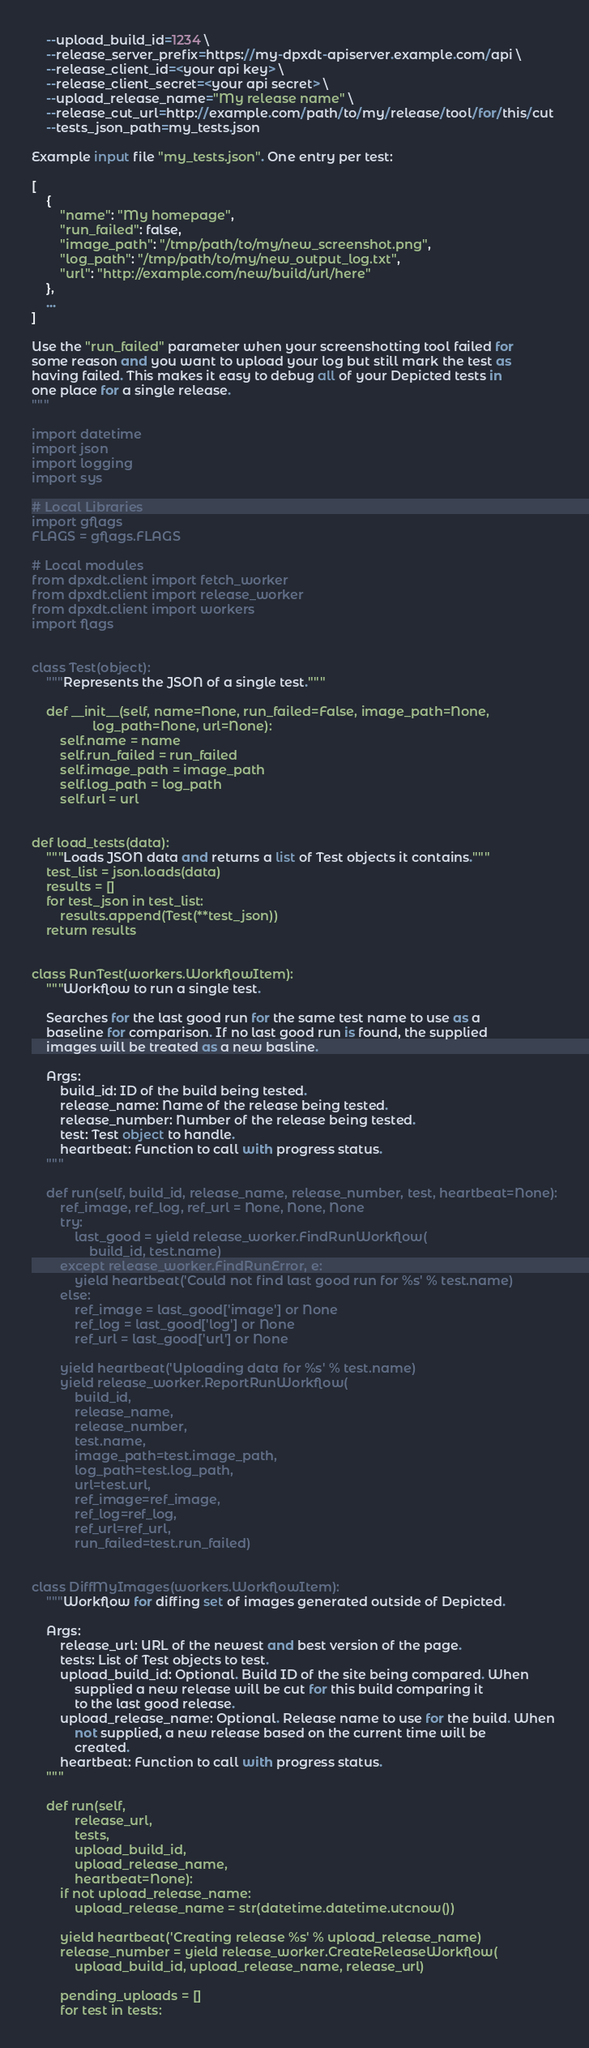<code> <loc_0><loc_0><loc_500><loc_500><_Python_>    --upload_build_id=1234 \
    --release_server_prefix=https://my-dpxdt-apiserver.example.com/api \
    --release_client_id=<your api key> \
    --release_client_secret=<your api secret> \
    --upload_release_name="My release name" \
    --release_cut_url=http://example.com/path/to/my/release/tool/for/this/cut
    --tests_json_path=my_tests.json

Example input file "my_tests.json". One entry per test:

[
    {
        "name": "My homepage",
        "run_failed": false,
        "image_path": "/tmp/path/to/my/new_screenshot.png",
        "log_path": "/tmp/path/to/my/new_output_log.txt",
        "url": "http://example.com/new/build/url/here"
    },
    ...
]

Use the "run_failed" parameter when your screenshotting tool failed for
some reason and you want to upload your log but still mark the test as
having failed. This makes it easy to debug all of your Depicted tests in
one place for a single release.
"""

import datetime
import json
import logging
import sys

# Local Libraries
import gflags
FLAGS = gflags.FLAGS

# Local modules
from dpxdt.client import fetch_worker
from dpxdt.client import release_worker
from dpxdt.client import workers
import flags


class Test(object):
    """Represents the JSON of a single test."""

    def __init__(self, name=None, run_failed=False, image_path=None,
                 log_path=None, url=None):
        self.name = name
        self.run_failed = run_failed
        self.image_path = image_path
        self.log_path = log_path
        self.url = url


def load_tests(data):
    """Loads JSON data and returns a list of Test objects it contains."""
    test_list = json.loads(data)
    results = []
    for test_json in test_list:
        results.append(Test(**test_json))
    return results


class RunTest(workers.WorkflowItem):
    """Workflow to run a single test.

    Searches for the last good run for the same test name to use as a
    baseline for comparison. If no last good run is found, the supplied
    images will be treated as a new basline.

    Args:
        build_id: ID of the build being tested.
        release_name: Name of the release being tested.
        release_number: Number of the release being tested.
        test: Test object to handle.
        heartbeat: Function to call with progress status.
    """

    def run(self, build_id, release_name, release_number, test, heartbeat=None):
        ref_image, ref_log, ref_url = None, None, None
        try:
            last_good = yield release_worker.FindRunWorkflow(
                build_id, test.name)
        except release_worker.FindRunError, e:
            yield heartbeat('Could not find last good run for %s' % test.name)
        else:
            ref_image = last_good['image'] or None
            ref_log = last_good['log'] or None
            ref_url = last_good['url'] or None

        yield heartbeat('Uploading data for %s' % test.name)
        yield release_worker.ReportRunWorkflow(
            build_id,
            release_name,
            release_number,
            test.name,
            image_path=test.image_path,
            log_path=test.log_path,
            url=test.url,
            ref_image=ref_image,
            ref_log=ref_log,
            ref_url=ref_url,
            run_failed=test.run_failed)


class DiffMyImages(workers.WorkflowItem):
    """Workflow for diffing set of images generated outside of Depicted.

    Args:
        release_url: URL of the newest and best version of the page.
        tests: List of Test objects to test.
        upload_build_id: Optional. Build ID of the site being compared. When
            supplied a new release will be cut for this build comparing it
            to the last good release.
        upload_release_name: Optional. Release name to use for the build. When
            not supplied, a new release based on the current time will be
            created.
        heartbeat: Function to call with progress status.
    """

    def run(self,
            release_url,
            tests,
            upload_build_id,
            upload_release_name,
            heartbeat=None):
        if not upload_release_name:
            upload_release_name = str(datetime.datetime.utcnow())

        yield heartbeat('Creating release %s' % upload_release_name)
        release_number = yield release_worker.CreateReleaseWorkflow(
            upload_build_id, upload_release_name, release_url)

        pending_uploads = []
        for test in tests:</code> 